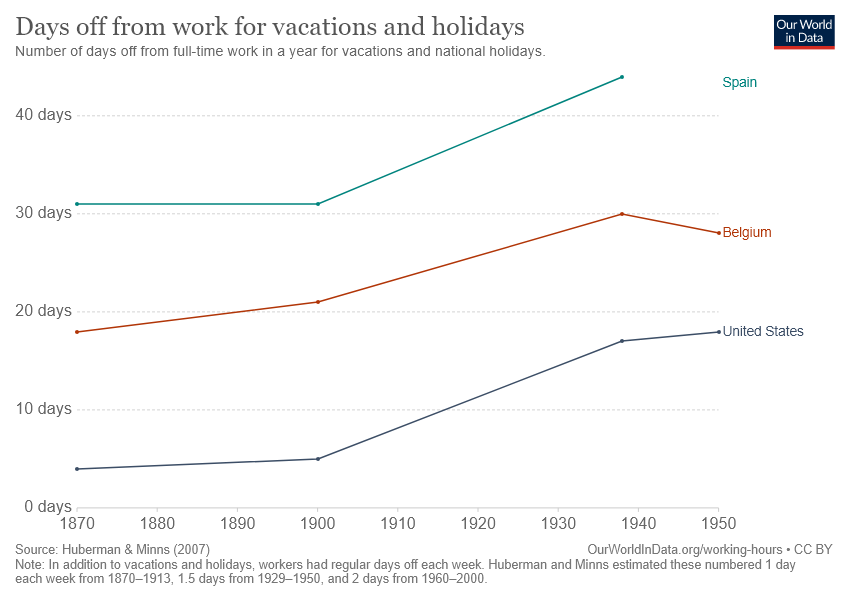Draw attention to some important aspects in this diagram. The United States has raised more data from the first data to the latest data than any other country. The starting year in the chart is 1870. 